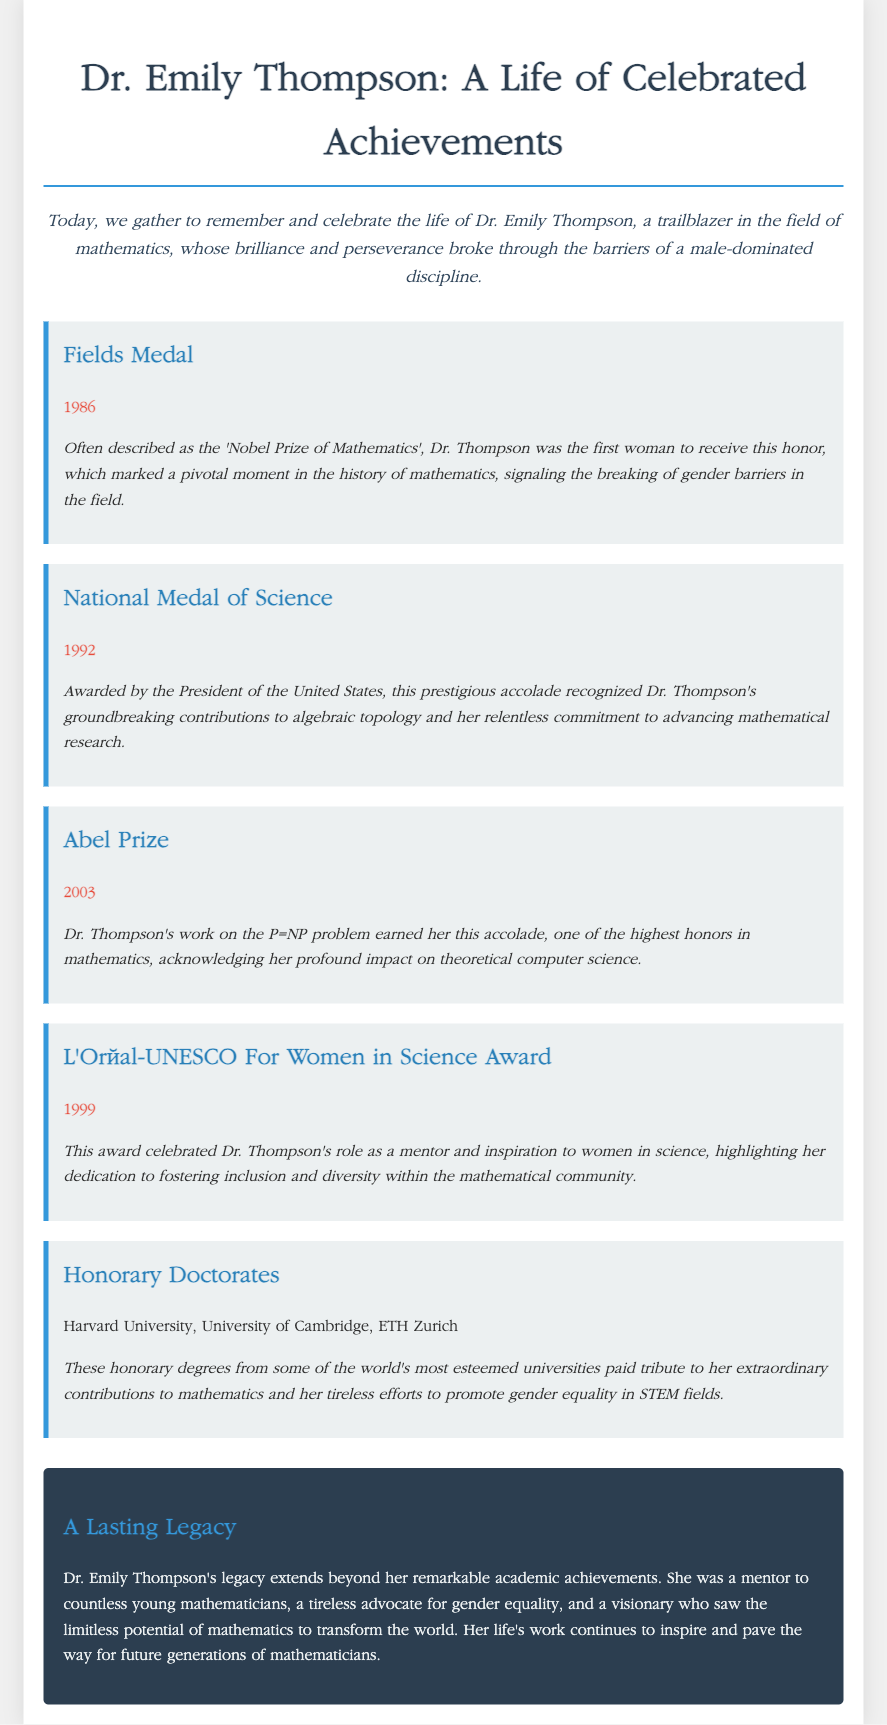What is the title of the document? The title indicates who the eulogy is about, which is Dr. Emily Thompson and describes her achievements.
Answer: Dr. Emily Thompson - A Life of Celebrated Achievements In what year did Dr. Thompson receive the Fields Medal? The year of the Fields Medal award is explicitly mentioned in the document, highlighting a significant achievement in her career.
Answer: 1986 What prestigious award did Dr. Thompson receive in 1992? This question seeks to identify one of the awards received by Dr. Thompson, as outlined in her accolades.
Answer: National Medal of Science Which award recognized Dr. Thompson's contributions to women in science? The specific award celebrates her role and contributions toward fostering inclusion and diversity in mathematics.
Answer: L'Oréal-UNESCO For Women in Science Award How many honorary doctorates did Dr. Thompson receive? This question checks the number of honorary degrees listed, reflecting her acknowledgment by esteemed institutions.
Answer: Three What is the significance of the Abel Prize mentioned in the document? The significance of the Abel Prize illustrates its importance as a recognition of her impact on theoretical computer science.
Answer: Highest honors in mathematics What role did Dr. Thompson have beyond her academic achievements? This question addresses her influence and contributions outside of her formal education and awards in the field of mathematics.
Answer: Mentor What does the document suggest about Dr. Thompson's legacy? This question seeks to summarize the overall message regarding what Dr. Thompson's life and career represent for future generations.
Answer: Inspire and pave the way 